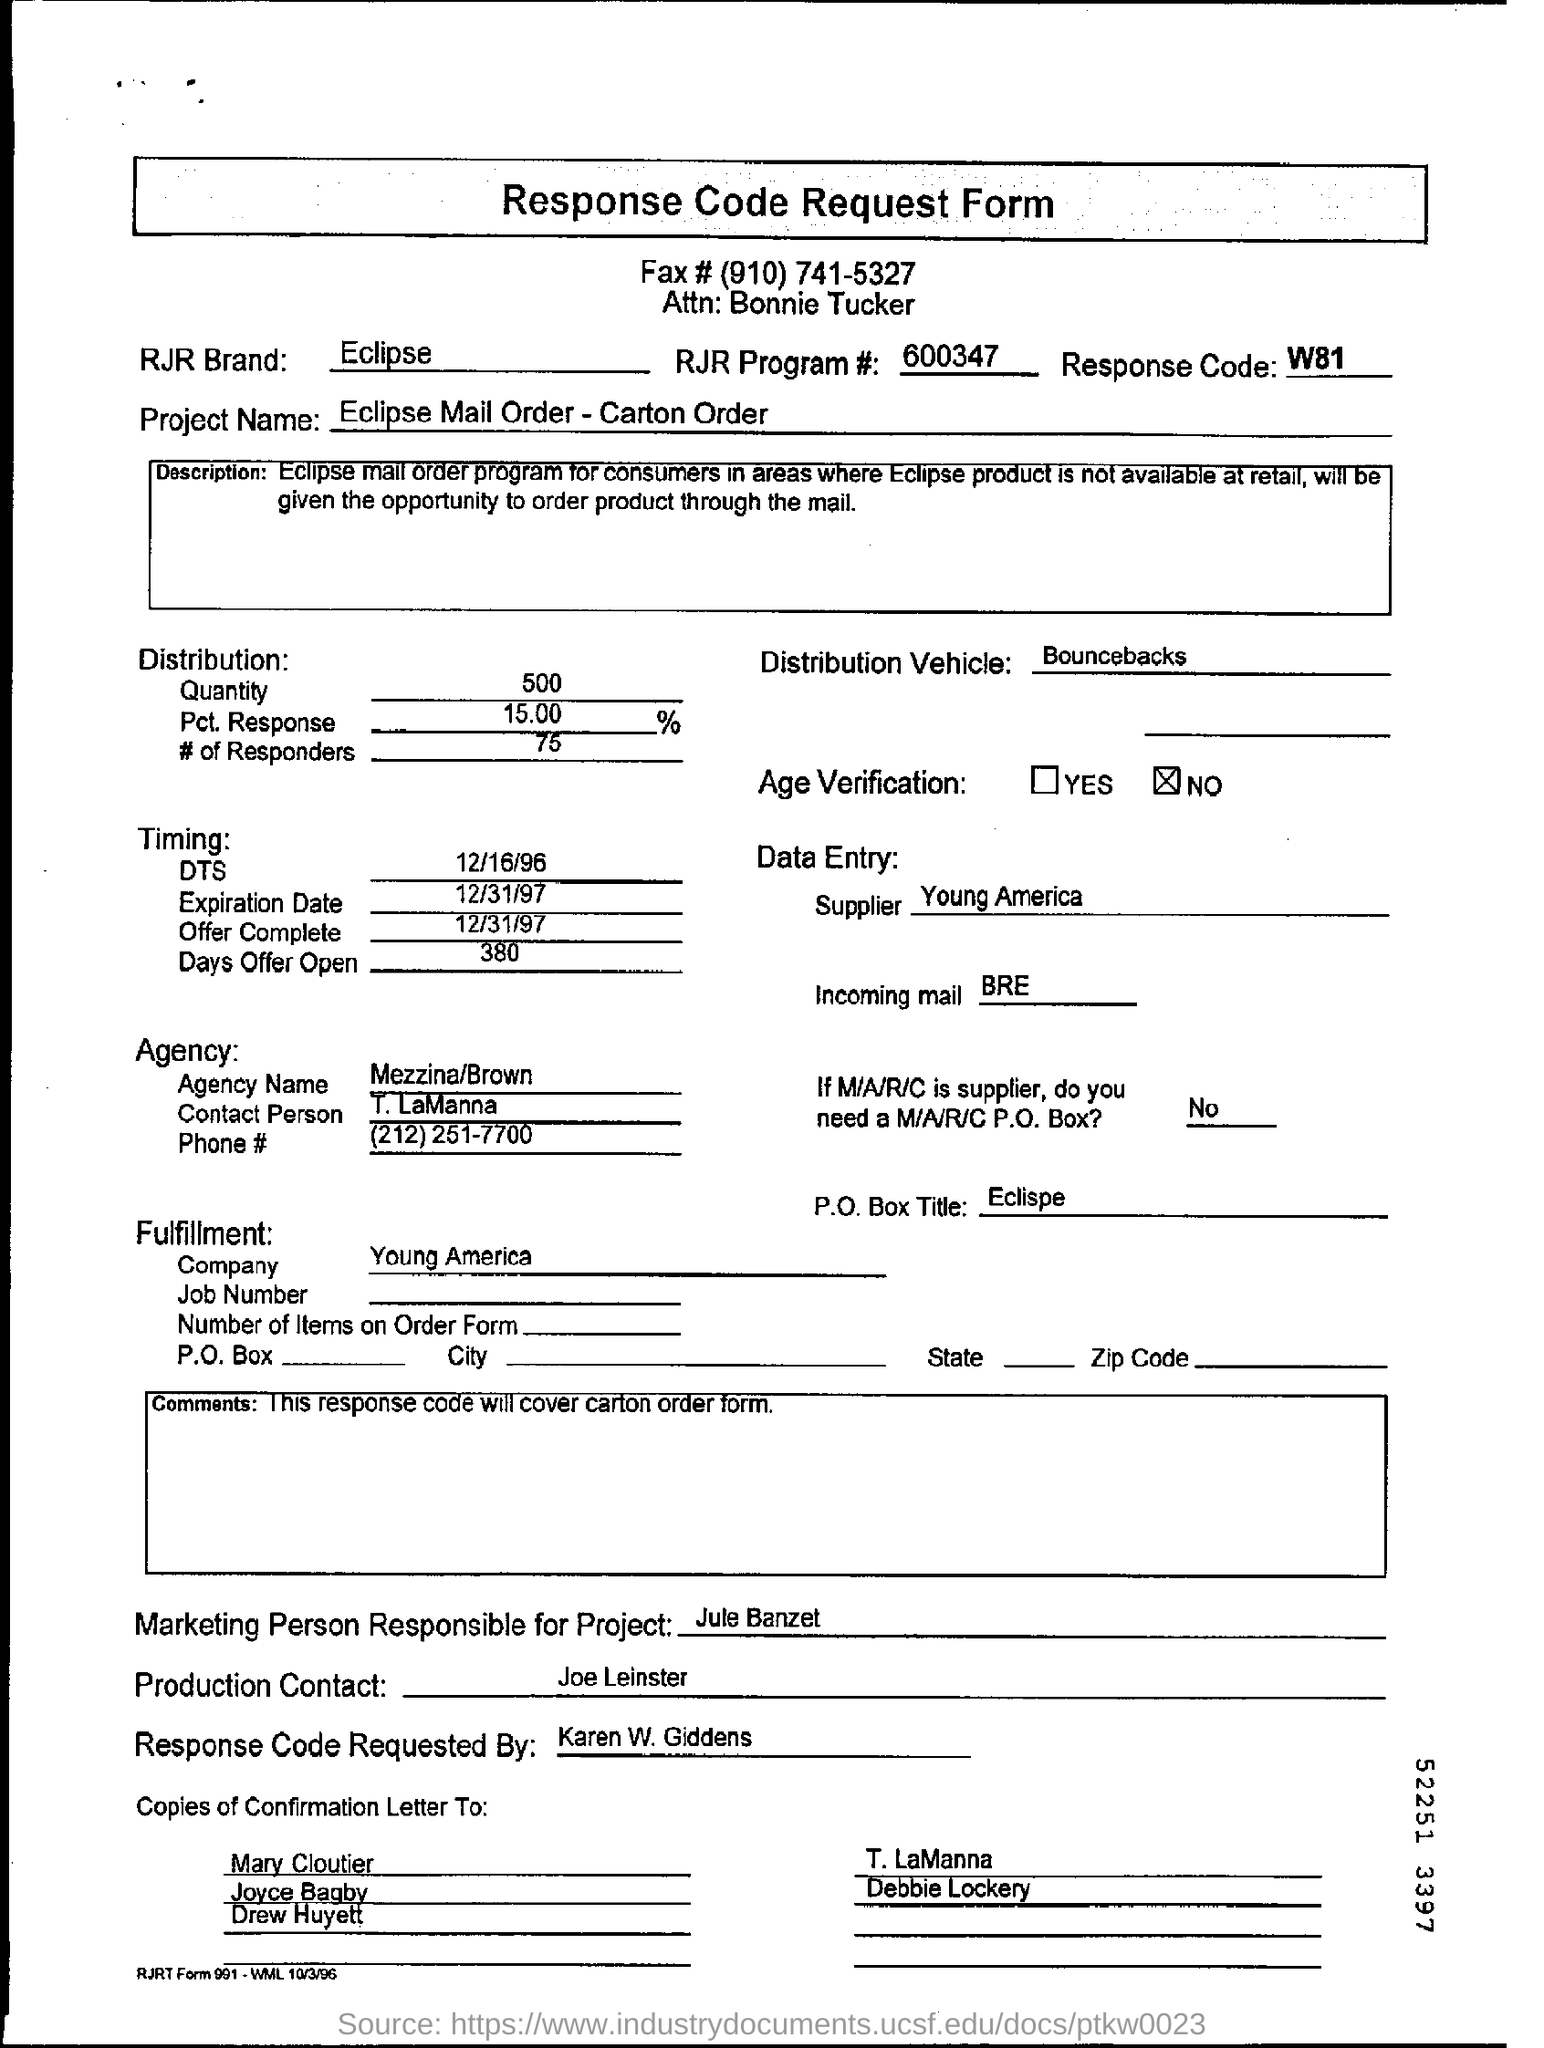Indicate a few pertinent items in this graphic. The response code is W81. The marketing person responsible for this project is Jule Banzet. The supplier is Young America. The Eclipse Mail Order - Carton Order project is a system that allows for the ordering and tracking of cartons. 